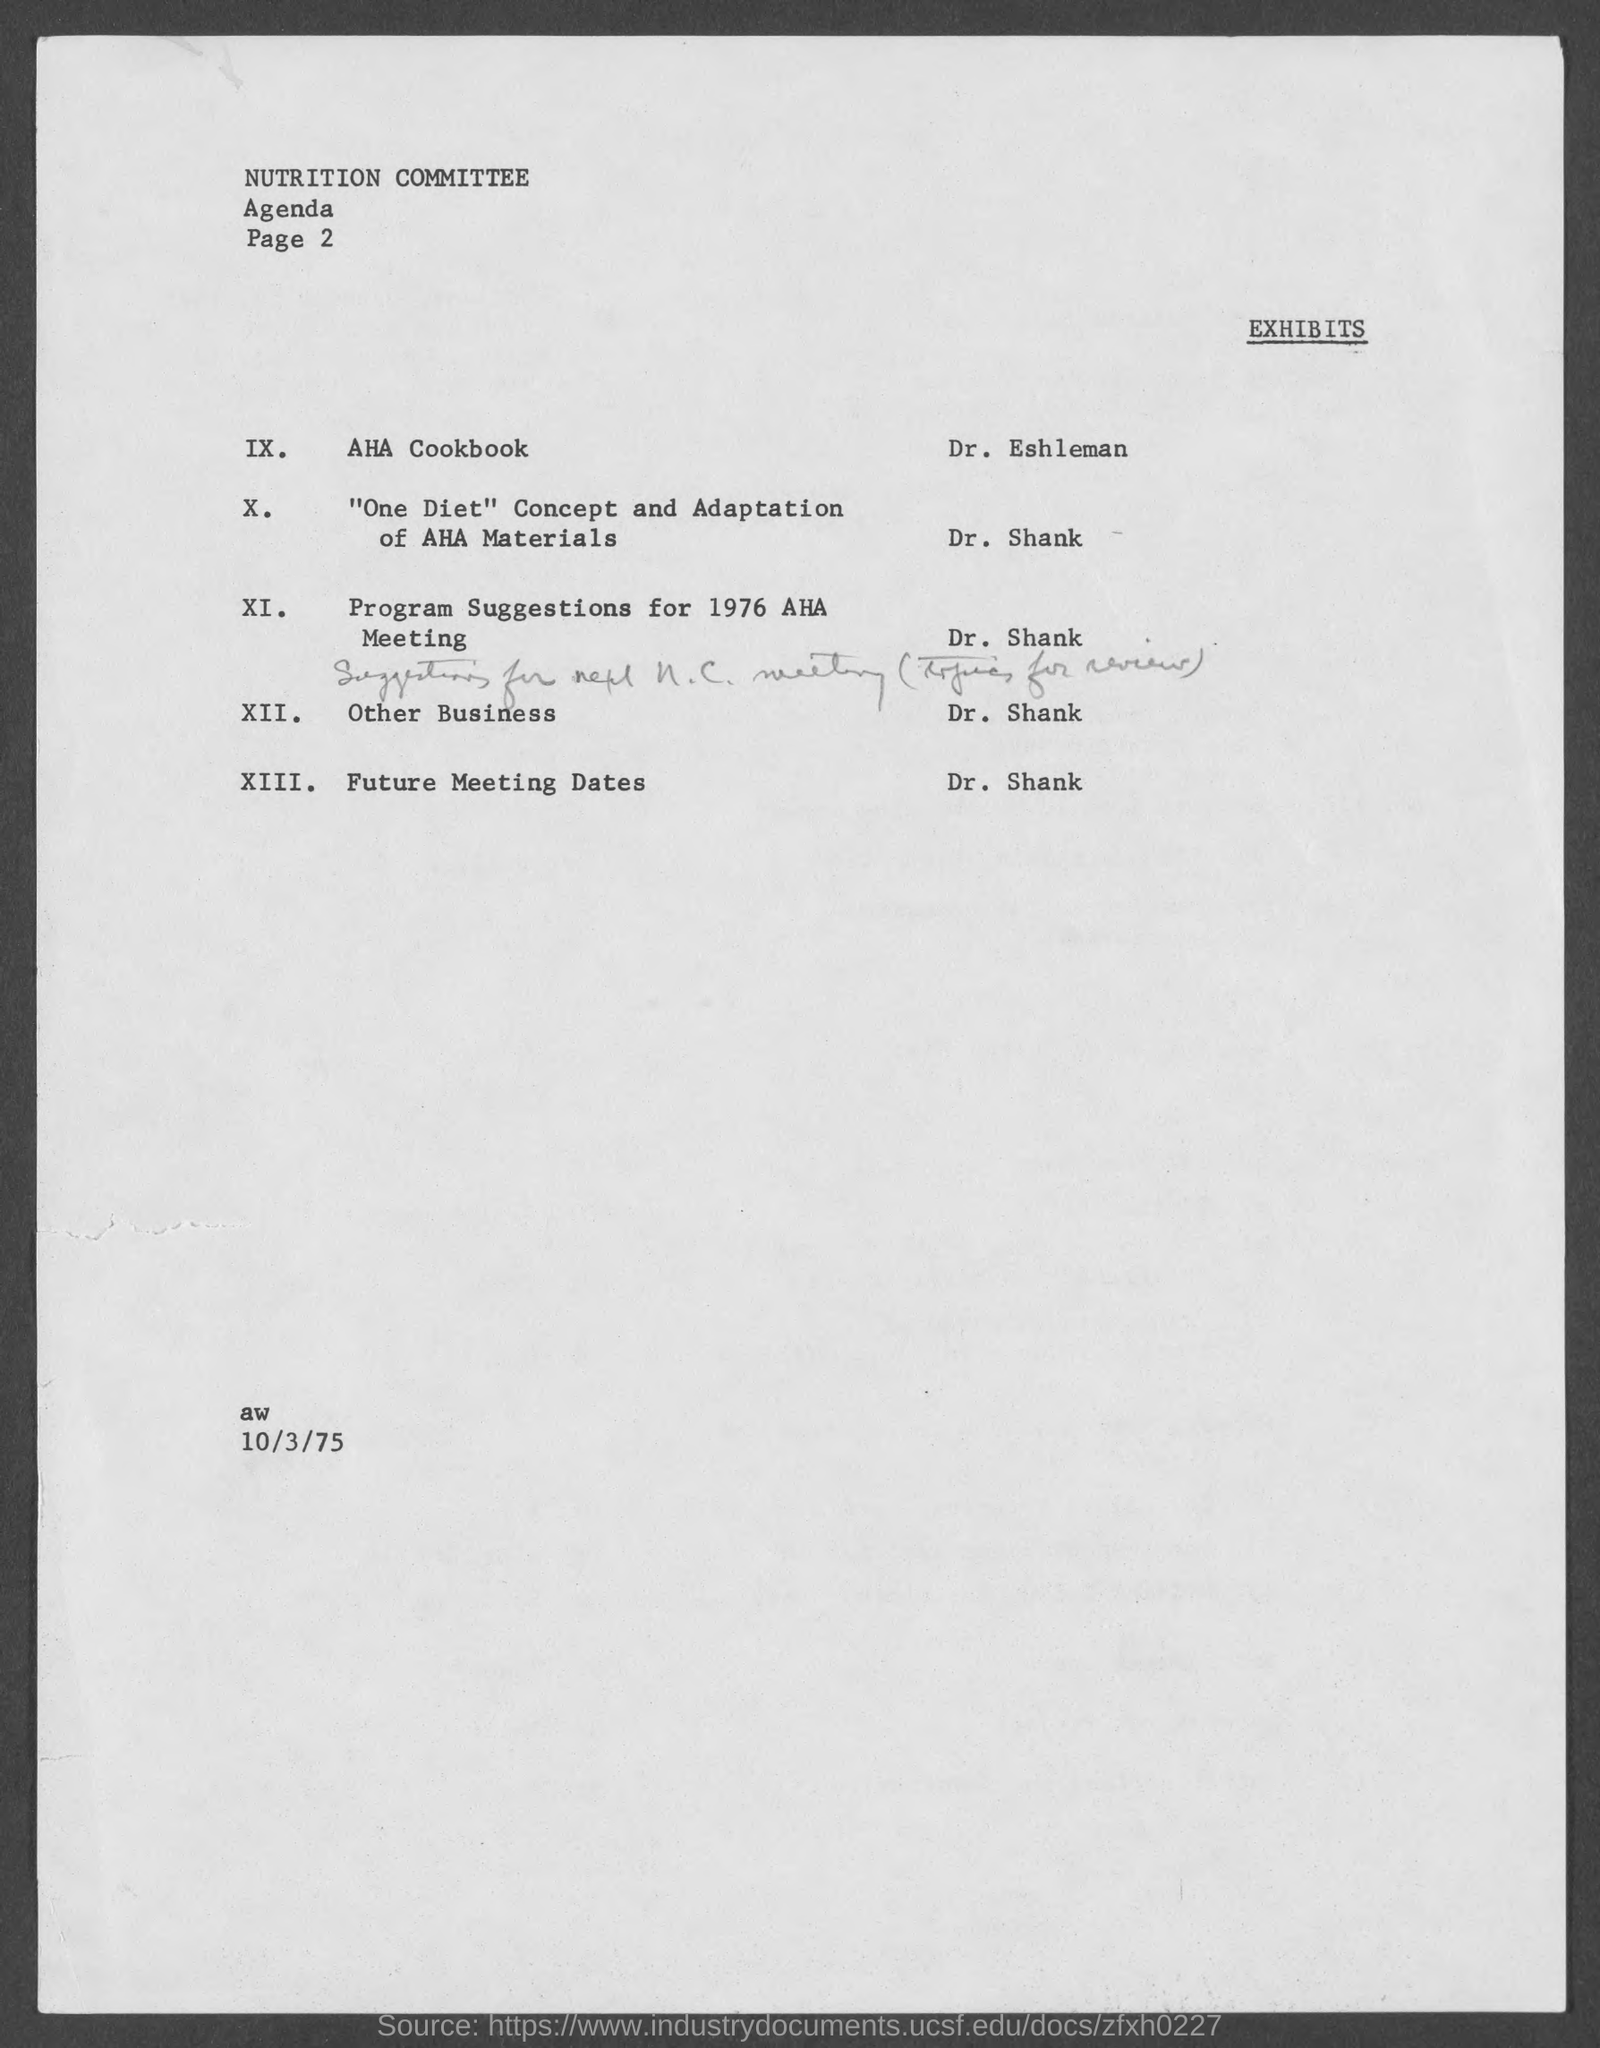Specify some key components in this picture. The date on the document is October 3, 1975. 